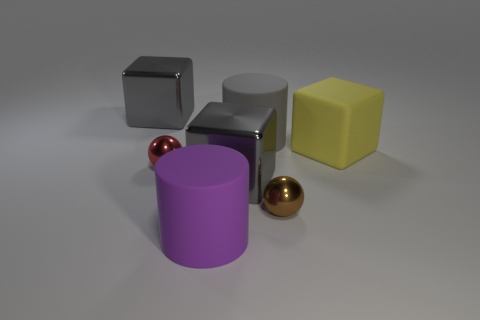Subtract all blue balls. How many gray blocks are left? 2 Add 2 purple rubber cylinders. How many objects exist? 9 Subtract all big yellow rubber cubes. How many cubes are left? 2 Subtract 1 blocks. How many blocks are left? 2 Subtract all cylinders. How many objects are left? 5 Add 7 shiny cubes. How many shiny cubes are left? 9 Add 7 brown shiny things. How many brown shiny things exist? 8 Subtract 0 cyan cylinders. How many objects are left? 7 Subtract all red blocks. Subtract all red balls. How many blocks are left? 3 Subtract all gray things. Subtract all cylinders. How many objects are left? 2 